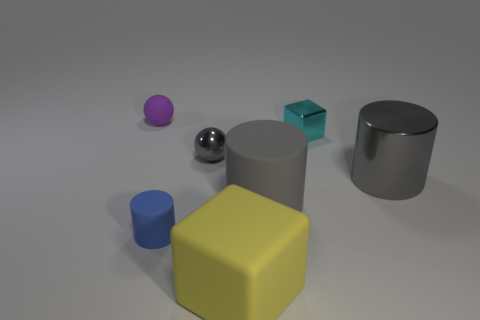Add 2 small red shiny things. How many objects exist? 9 Subtract all cylinders. How many objects are left? 4 Add 7 large yellow matte things. How many large yellow matte things are left? 8 Add 3 gray balls. How many gray balls exist? 4 Subtract 0 purple cylinders. How many objects are left? 7 Subtract all red objects. Subtract all purple matte objects. How many objects are left? 6 